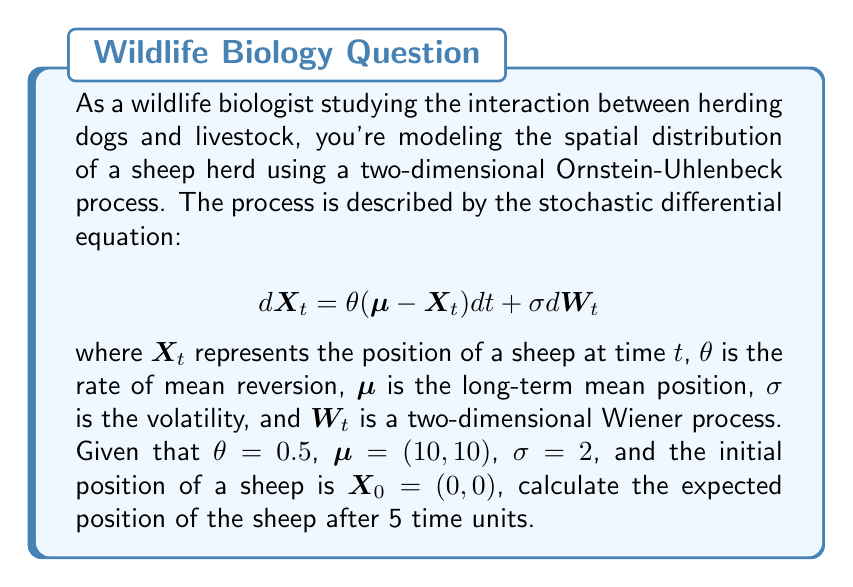Teach me how to tackle this problem. To solve this problem, we need to use the properties of the Ornstein-Uhlenbeck process. The expected value of an Ornstein-Uhlenbeck process at time $t$, given an initial position $X_0$, is:

$$E[X_t | X_0] = \mu + (X_0 - \mu)e^{-\theta t}$$

Let's break down the solution step-by-step:

1) We are given:
   $\theta = 0.5$
   $\mu = (10, 10)$
   $X_0 = (0, 0)$
   $t = 5$

2) Let's substitute these values into the formula:

   $$E[X_5 | X_0] = (10, 10) + ((0, 0) - (10, 10))e^{-0.5 \cdot 5}$$

3) Simplify the exponent:
   $$e^{-0.5 \cdot 5} = e^{-2.5} \approx 0.0821$$

4) Now, let's calculate the vector subtraction inside the parentheses:
   $$(0, 0) - (10, 10) = (-10, -10)$$

5) Multiply this vector by $e^{-2.5}$:
   $$(-10, -10) \cdot 0.0821 \approx (-0.821, -0.821)$$

6) Finally, add this to $\mu$:
   $$(10, 10) + (-0.821, -0.821) \approx (9.179, 9.179)$$

Therefore, the expected position of the sheep after 5 time units is approximately (9.179, 9.179).
Answer: $$(9.179, 9.179)$$ 